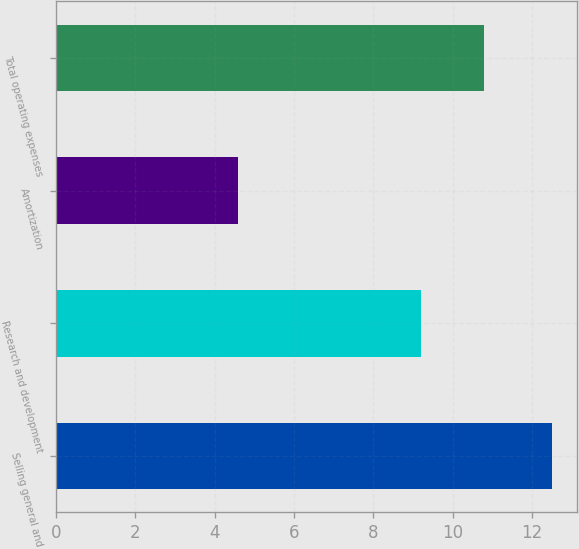<chart> <loc_0><loc_0><loc_500><loc_500><bar_chart><fcel>Selling general and<fcel>Research and development<fcel>Amortization<fcel>Total operating expenses<nl><fcel>12.5<fcel>9.2<fcel>4.6<fcel>10.8<nl></chart> 